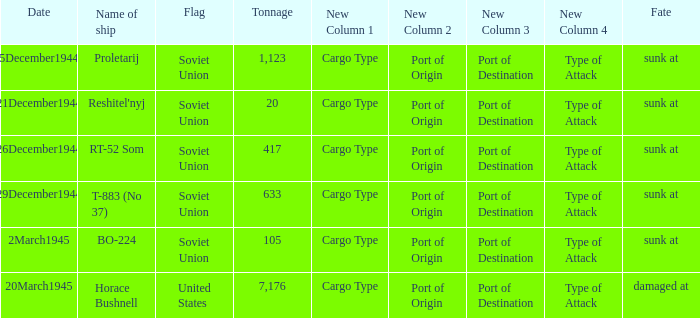What is the average tonnage of the ship named proletarij? 1123.0. 